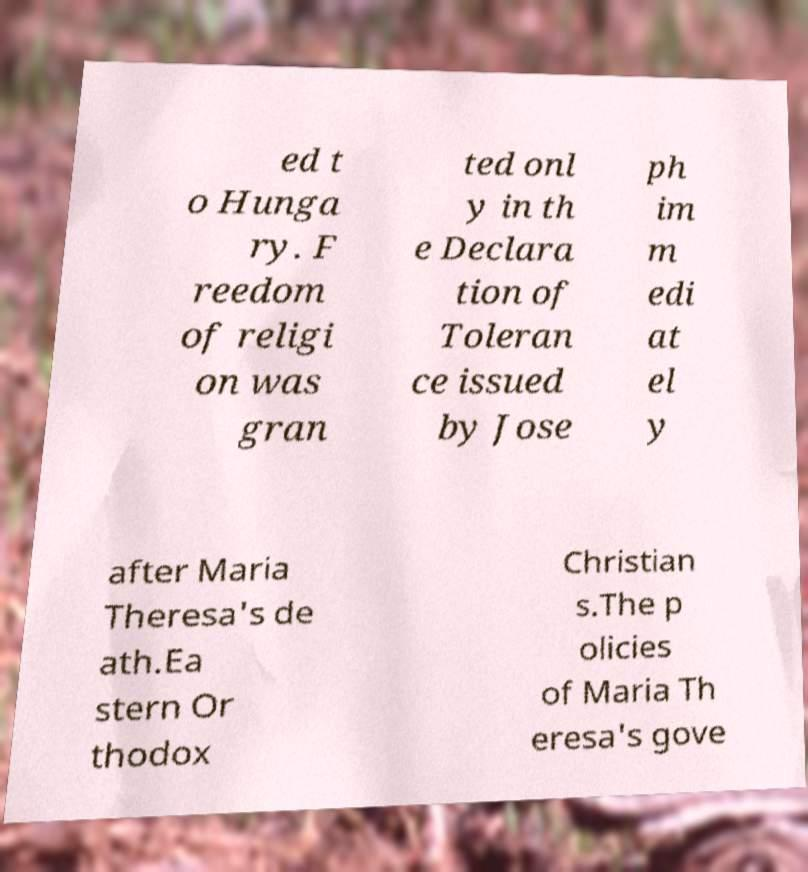Can you read and provide the text displayed in the image?This photo seems to have some interesting text. Can you extract and type it out for me? ed t o Hunga ry. F reedom of religi on was gran ted onl y in th e Declara tion of Toleran ce issued by Jose ph im m edi at el y after Maria Theresa's de ath.Ea stern Or thodox Christian s.The p olicies of Maria Th eresa's gove 